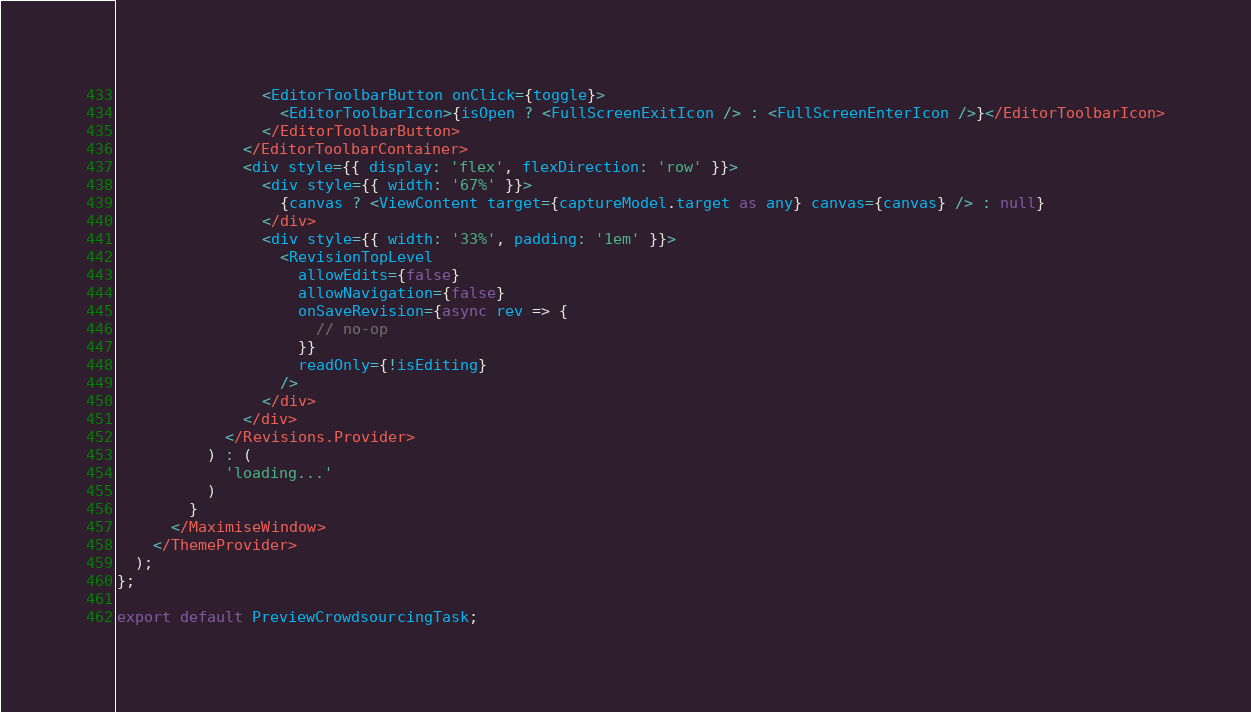Convert code to text. <code><loc_0><loc_0><loc_500><loc_500><_TypeScript_>                <EditorToolbarButton onClick={toggle}>
                  <EditorToolbarIcon>{isOpen ? <FullScreenExitIcon /> : <FullScreenEnterIcon />}</EditorToolbarIcon>
                </EditorToolbarButton>
              </EditorToolbarContainer>
              <div style={{ display: 'flex', flexDirection: 'row' }}>
                <div style={{ width: '67%' }}>
                  {canvas ? <ViewContent target={captureModel.target as any} canvas={canvas} /> : null}
                </div>
                <div style={{ width: '33%', padding: '1em' }}>
                  <RevisionTopLevel
                    allowEdits={false}
                    allowNavigation={false}
                    onSaveRevision={async rev => {
                      // no-op
                    }}
                    readOnly={!isEditing}
                  />
                </div>
              </div>
            </Revisions.Provider>
          ) : (
            'loading...'
          )
        }
      </MaximiseWindow>
    </ThemeProvider>
  );
};

export default PreviewCrowdsourcingTask;
</code> 